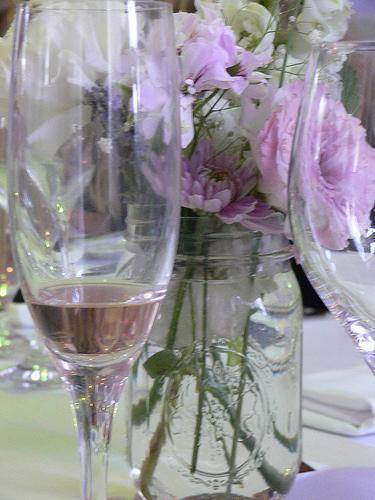How many glasses are shown in the foreground?
Give a very brief answer. 2. How many wine glasses are there?
Give a very brief answer. 3. How many mason jars on the table?
Give a very brief answer. 1. How many wine glasses on the table?
Give a very brief answer. 2. How many glasses are empty?
Give a very brief answer. 1. 